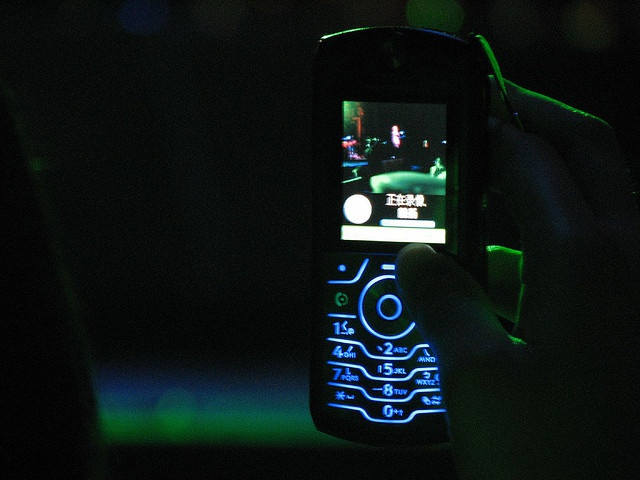Describe the objects in this image and their specific colors. I can see people in black, darkgreen, navy, and green tones and cell phone in black, white, navy, and blue tones in this image. 